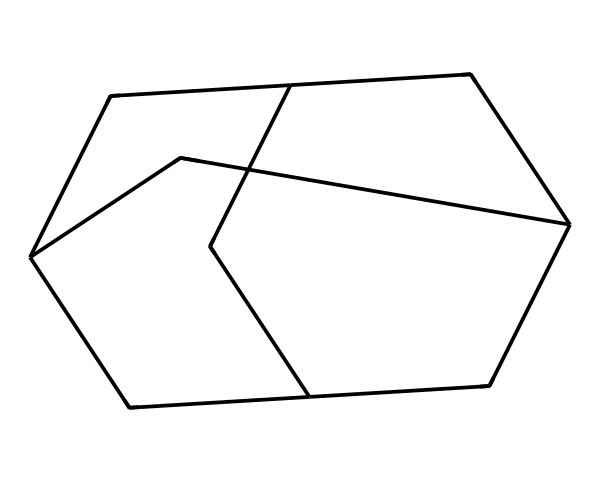What is the name of this chemical? The SMILES representation corresponds to the structure of adamantane, which is a well-known cage hydrocarbon.
Answer: adamantane How many carbon atoms are in adamantane? By analyzing the chemical structure represented in the SMILES, we can count the number of carbon atoms present, which is 10.
Answer: 10 How many hydrogen atoms are in adamantane? Each carbon in adamantane typically bonds to two hydrogen atoms, but since it's a cage structure, we adjust for bonding configurations. Thus, the total hydrogen count is 16.
Answer: 16 What is the type of this chemical compound? This is a saturated hydrocarbon, specifically a cage compound due to its three-dimensional structure.
Answer: saturated hydrocarbon What is the main feature of cage compounds like adamantane? The defining feature of cage compounds is their unique three-dimensional framework, allowing for a compact shape and distinct physical properties.
Answer: three-dimensional framework What type of interactions might adamantane facilitate in pharmaceuticals? The compact structure of adamantane can facilitate hydrophobic interactions and molecular encapsulation, which are critical in drug design and delivery systems.
Answer: hydrophobic interactions How many fused rings does adamantane contain? The structure of adamantane consists of a framework that can be visualized as three interconnected cyclohexane rings, making the count three fused rings.
Answer: three fused rings 